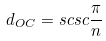Convert formula to latex. <formula><loc_0><loc_0><loc_500><loc_500>d _ { O C } = s c s c \frac { \pi } { n }</formula> 